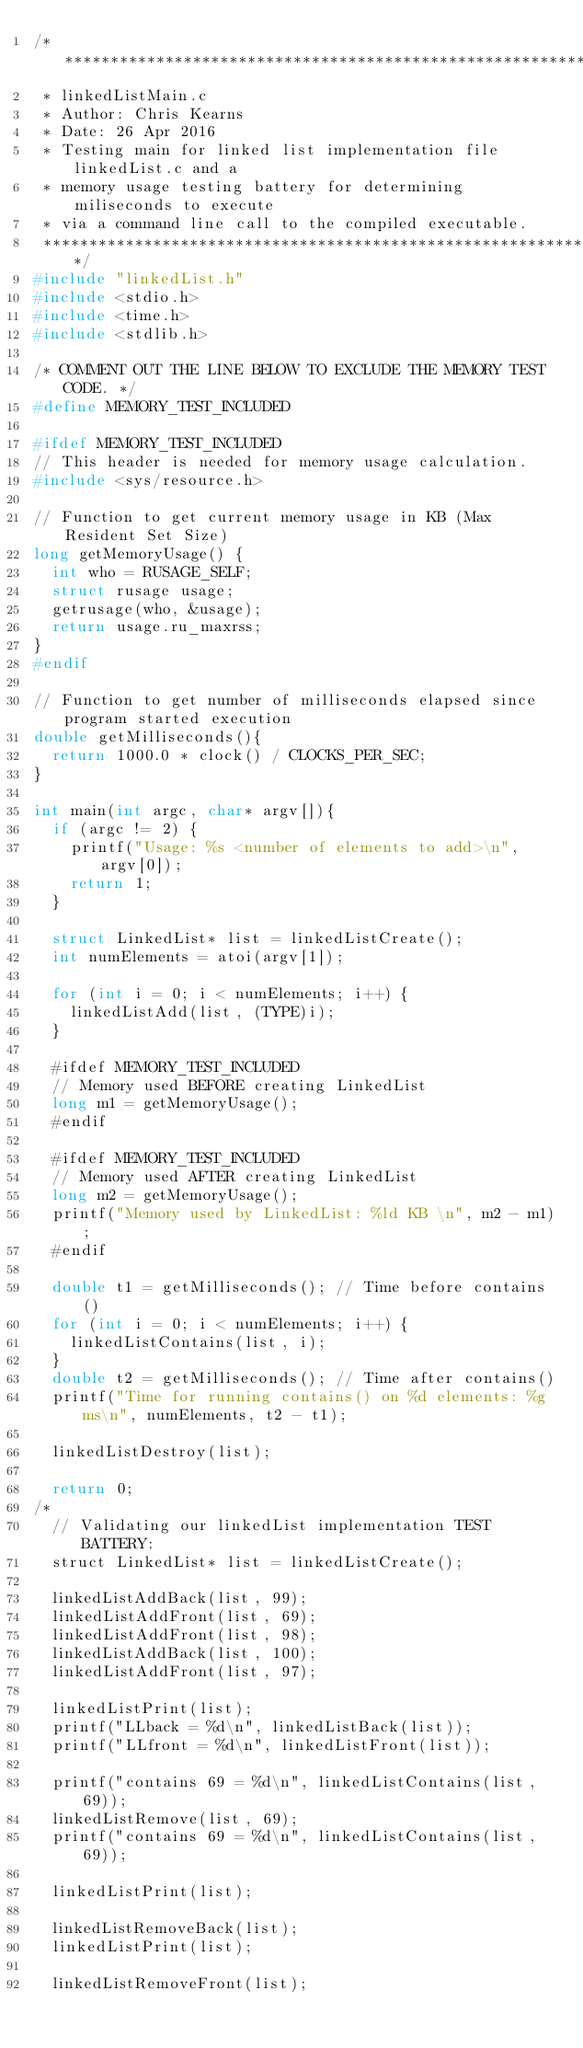<code> <loc_0><loc_0><loc_500><loc_500><_C_>/**************************************************************************
 * linkedListMain.c
 * Author: Chris Kearns
 * Date: 26 Apr 2016
 * Testing main for linked list implementation file linkedList.c and a 
 * memory usage testing battery for determining miliseconds to execute
 * via a command line call to the compiled executable.
 *************************************************************************/
#include "linkedList.h"
#include <stdio.h>
#include <time.h>
#include <stdlib.h>

/* COMMENT OUT THE LINE BELOW TO EXCLUDE THE MEMORY TEST CODE. */
#define MEMORY_TEST_INCLUDED

#ifdef MEMORY_TEST_INCLUDED
// This header is needed for memory usage calculation.
#include <sys/resource.h> 

// Function to get current memory usage in KB (Max Resident Set Size)
long getMemoryUsage() {
	int who = RUSAGE_SELF; 
	struct rusage usage; 
	getrusage(who, &usage);	
	return usage.ru_maxrss;
}
#endif

// Function to get number of milliseconds elapsed since program started execution
double getMilliseconds(){
	return 1000.0 * clock() / CLOCKS_PER_SEC;
}

int main(int argc, char* argv[]){
	if (argc != 2) {
		printf("Usage: %s <number of elements to add>\n", argv[0]);
		return 1;
	}

	struct LinkedList* list = linkedListCreate();
	int numElements = atoi(argv[1]);

	for (int i = 0; i < numElements; i++) {
		linkedListAdd(list, (TYPE)i);
	}

	#ifdef MEMORY_TEST_INCLUDED
	// Memory used BEFORE creating LinkedList
	long m1 = getMemoryUsage();
	#endif

	#ifdef MEMORY_TEST_INCLUDED
	// Memory used AFTER creating LinkedList
	long m2 = getMemoryUsage();
	printf("Memory used by LinkedList: %ld KB \n", m2 - m1);
	#endif

	double t1 = getMilliseconds(); // Time before contains()
	for (int i = 0; i < numElements; i++) {
		linkedListContains(list, i);
	}
	double t2 = getMilliseconds(); // Time after contains()
	printf("Time for running contains() on %d elements: %g ms\n", numElements, t2 - t1);

	linkedListDestroy(list);

	return 0;
/*
	// Validating our linkedList implementation TEST BATTERY:
	struct LinkedList* list = linkedListCreate();

	linkedListAddBack(list, 99);
	linkedListAddFront(list, 69);
	linkedListAddFront(list, 98);
	linkedListAddBack(list, 100);
	linkedListAddFront(list, 97);

	linkedListPrint(list);
	printf("LLback = %d\n", linkedListBack(list));
	printf("LLfront = %d\n", linkedListFront(list));

	printf("contains 69 = %d\n", linkedListContains(list, 69));
	linkedListRemove(list, 69);
	printf("contains 69 = %d\n", linkedListContains(list, 69));

	linkedListPrint(list);

	linkedListRemoveBack(list);
	linkedListPrint(list);

	linkedListRemoveFront(list);</code> 